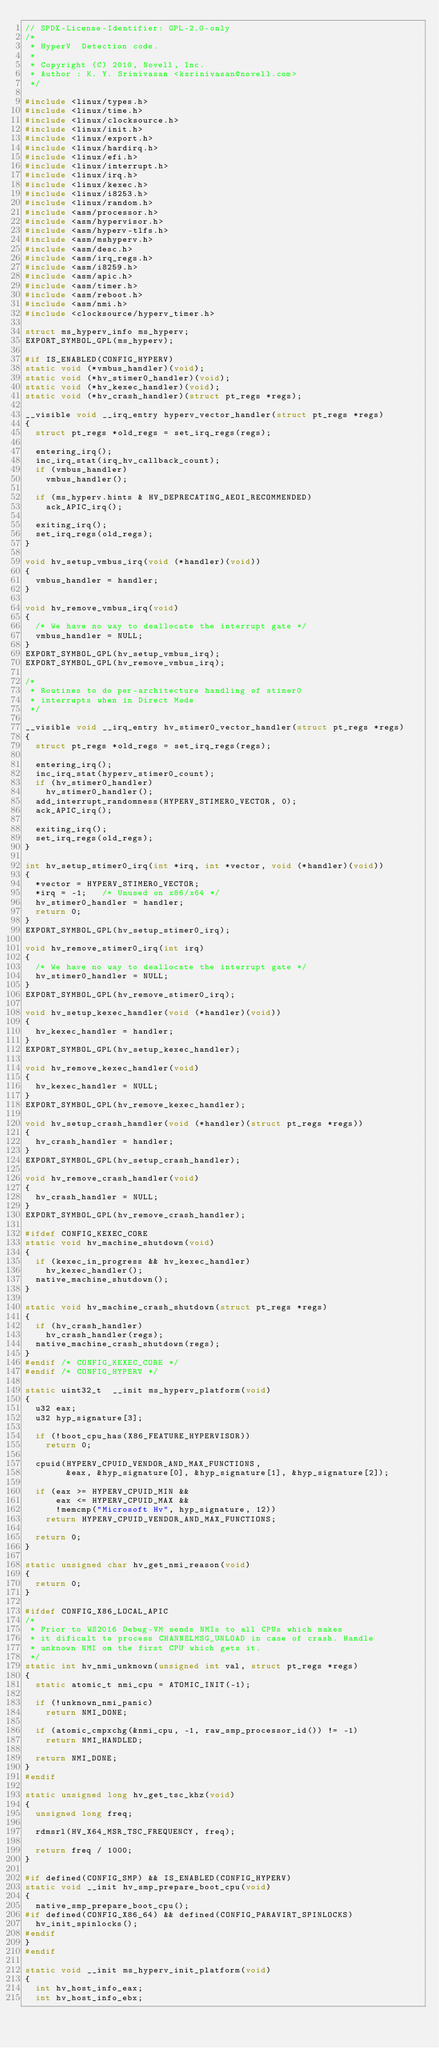Convert code to text. <code><loc_0><loc_0><loc_500><loc_500><_C_>// SPDX-License-Identifier: GPL-2.0-only
/*
 * HyperV  Detection code.
 *
 * Copyright (C) 2010, Novell, Inc.
 * Author : K. Y. Srinivasan <ksrinivasan@novell.com>
 */

#include <linux/types.h>
#include <linux/time.h>
#include <linux/clocksource.h>
#include <linux/init.h>
#include <linux/export.h>
#include <linux/hardirq.h>
#include <linux/efi.h>
#include <linux/interrupt.h>
#include <linux/irq.h>
#include <linux/kexec.h>
#include <linux/i8253.h>
#include <linux/random.h>
#include <asm/processor.h>
#include <asm/hypervisor.h>
#include <asm/hyperv-tlfs.h>
#include <asm/mshyperv.h>
#include <asm/desc.h>
#include <asm/irq_regs.h>
#include <asm/i8259.h>
#include <asm/apic.h>
#include <asm/timer.h>
#include <asm/reboot.h>
#include <asm/nmi.h>
#include <clocksource/hyperv_timer.h>

struct ms_hyperv_info ms_hyperv;
EXPORT_SYMBOL_GPL(ms_hyperv);

#if IS_ENABLED(CONFIG_HYPERV)
static void (*vmbus_handler)(void);
static void (*hv_stimer0_handler)(void);
static void (*hv_kexec_handler)(void);
static void (*hv_crash_handler)(struct pt_regs *regs);

__visible void __irq_entry hyperv_vector_handler(struct pt_regs *regs)
{
	struct pt_regs *old_regs = set_irq_regs(regs);

	entering_irq();
	inc_irq_stat(irq_hv_callback_count);
	if (vmbus_handler)
		vmbus_handler();

	if (ms_hyperv.hints & HV_DEPRECATING_AEOI_RECOMMENDED)
		ack_APIC_irq();

	exiting_irq();
	set_irq_regs(old_regs);
}

void hv_setup_vmbus_irq(void (*handler)(void))
{
	vmbus_handler = handler;
}

void hv_remove_vmbus_irq(void)
{
	/* We have no way to deallocate the interrupt gate */
	vmbus_handler = NULL;
}
EXPORT_SYMBOL_GPL(hv_setup_vmbus_irq);
EXPORT_SYMBOL_GPL(hv_remove_vmbus_irq);

/*
 * Routines to do per-architecture handling of stimer0
 * interrupts when in Direct Mode
 */

__visible void __irq_entry hv_stimer0_vector_handler(struct pt_regs *regs)
{
	struct pt_regs *old_regs = set_irq_regs(regs);

	entering_irq();
	inc_irq_stat(hyperv_stimer0_count);
	if (hv_stimer0_handler)
		hv_stimer0_handler();
	add_interrupt_randomness(HYPERV_STIMER0_VECTOR, 0);
	ack_APIC_irq();

	exiting_irq();
	set_irq_regs(old_regs);
}

int hv_setup_stimer0_irq(int *irq, int *vector, void (*handler)(void))
{
	*vector = HYPERV_STIMER0_VECTOR;
	*irq = -1;   /* Unused on x86/x64 */
	hv_stimer0_handler = handler;
	return 0;
}
EXPORT_SYMBOL_GPL(hv_setup_stimer0_irq);

void hv_remove_stimer0_irq(int irq)
{
	/* We have no way to deallocate the interrupt gate */
	hv_stimer0_handler = NULL;
}
EXPORT_SYMBOL_GPL(hv_remove_stimer0_irq);

void hv_setup_kexec_handler(void (*handler)(void))
{
	hv_kexec_handler = handler;
}
EXPORT_SYMBOL_GPL(hv_setup_kexec_handler);

void hv_remove_kexec_handler(void)
{
	hv_kexec_handler = NULL;
}
EXPORT_SYMBOL_GPL(hv_remove_kexec_handler);

void hv_setup_crash_handler(void (*handler)(struct pt_regs *regs))
{
	hv_crash_handler = handler;
}
EXPORT_SYMBOL_GPL(hv_setup_crash_handler);

void hv_remove_crash_handler(void)
{
	hv_crash_handler = NULL;
}
EXPORT_SYMBOL_GPL(hv_remove_crash_handler);

#ifdef CONFIG_KEXEC_CORE
static void hv_machine_shutdown(void)
{
	if (kexec_in_progress && hv_kexec_handler)
		hv_kexec_handler();
	native_machine_shutdown();
}

static void hv_machine_crash_shutdown(struct pt_regs *regs)
{
	if (hv_crash_handler)
		hv_crash_handler(regs);
	native_machine_crash_shutdown(regs);
}
#endif /* CONFIG_KEXEC_CORE */
#endif /* CONFIG_HYPERV */

static uint32_t  __init ms_hyperv_platform(void)
{
	u32 eax;
	u32 hyp_signature[3];

	if (!boot_cpu_has(X86_FEATURE_HYPERVISOR))
		return 0;

	cpuid(HYPERV_CPUID_VENDOR_AND_MAX_FUNCTIONS,
	      &eax, &hyp_signature[0], &hyp_signature[1], &hyp_signature[2]);

	if (eax >= HYPERV_CPUID_MIN &&
	    eax <= HYPERV_CPUID_MAX &&
	    !memcmp("Microsoft Hv", hyp_signature, 12))
		return HYPERV_CPUID_VENDOR_AND_MAX_FUNCTIONS;

	return 0;
}

static unsigned char hv_get_nmi_reason(void)
{
	return 0;
}

#ifdef CONFIG_X86_LOCAL_APIC
/*
 * Prior to WS2016 Debug-VM sends NMIs to all CPUs which makes
 * it dificult to process CHANNELMSG_UNLOAD in case of crash. Handle
 * unknown NMI on the first CPU which gets it.
 */
static int hv_nmi_unknown(unsigned int val, struct pt_regs *regs)
{
	static atomic_t nmi_cpu = ATOMIC_INIT(-1);

	if (!unknown_nmi_panic)
		return NMI_DONE;

	if (atomic_cmpxchg(&nmi_cpu, -1, raw_smp_processor_id()) != -1)
		return NMI_HANDLED;

	return NMI_DONE;
}
#endif

static unsigned long hv_get_tsc_khz(void)
{
	unsigned long freq;

	rdmsrl(HV_X64_MSR_TSC_FREQUENCY, freq);

	return freq / 1000;
}

#if defined(CONFIG_SMP) && IS_ENABLED(CONFIG_HYPERV)
static void __init hv_smp_prepare_boot_cpu(void)
{
	native_smp_prepare_boot_cpu();
#if defined(CONFIG_X86_64) && defined(CONFIG_PARAVIRT_SPINLOCKS)
	hv_init_spinlocks();
#endif
}
#endif

static void __init ms_hyperv_init_platform(void)
{
	int hv_host_info_eax;
	int hv_host_info_ebx;</code> 